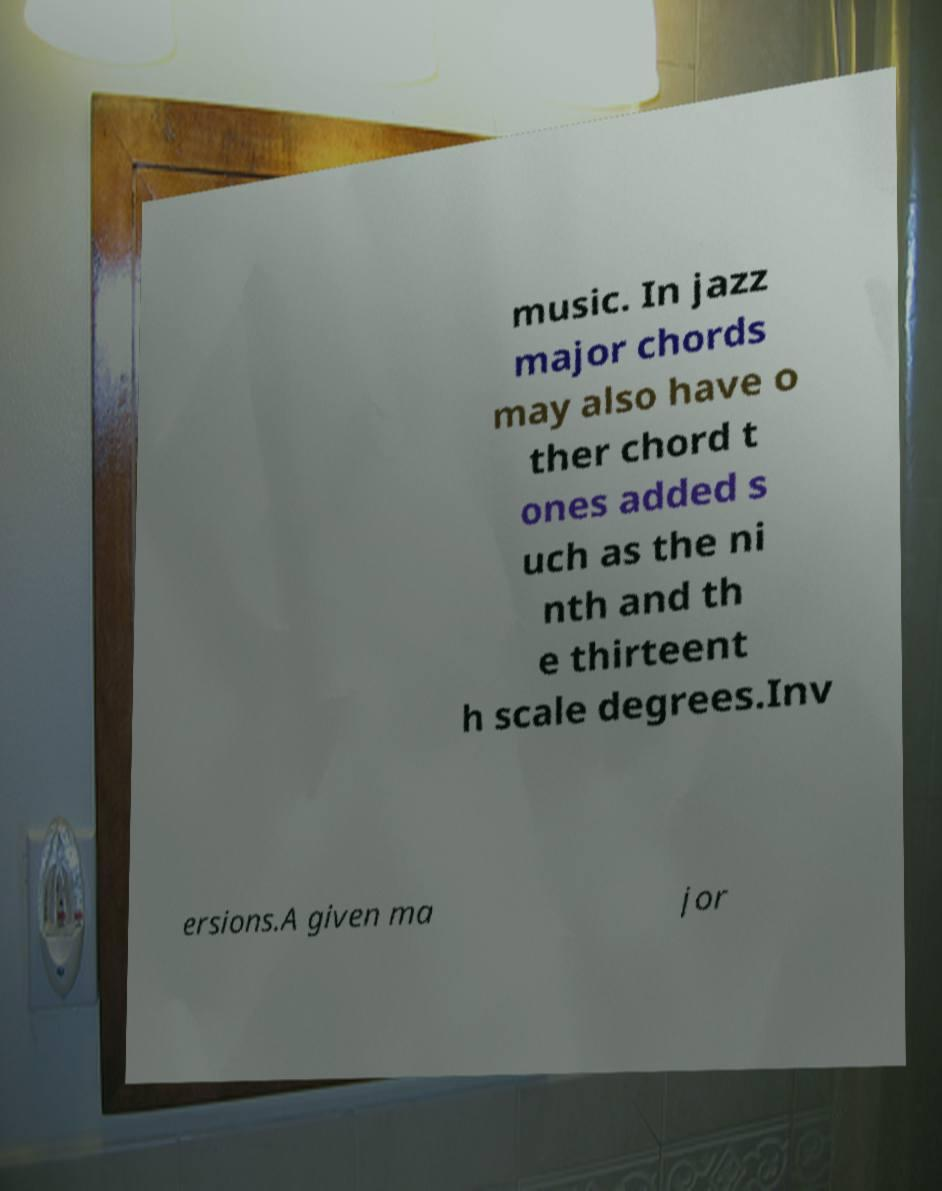For documentation purposes, I need the text within this image transcribed. Could you provide that? music. In jazz major chords may also have o ther chord t ones added s uch as the ni nth and th e thirteent h scale degrees.Inv ersions.A given ma jor 